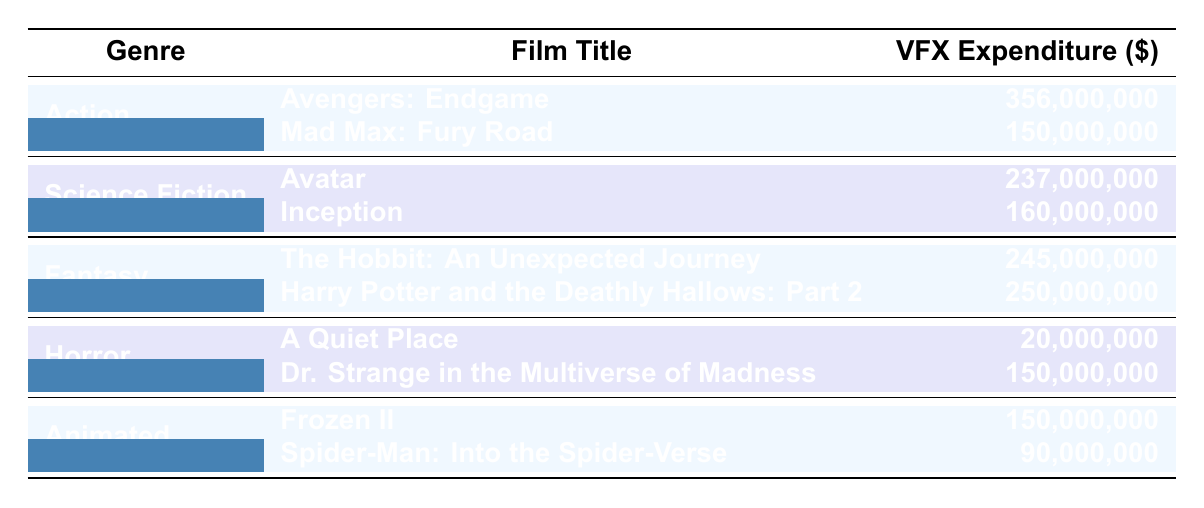What is the highest VFX expenditure in the table? Looking through the table, the highest VFX expenditure is for the film "Avengers: Endgame" which has an expenditure of 356,000,000.
Answer: 356,000,000 How much was spent on VFX for action films? For action films, the expenditures on VFX are 356,000,000 for "Avengers: Endgame" and 150,000,000 for "Mad Max: Fury Road". Adding these gives 356,000,000 + 150,000,000 = 506,000,000.
Answer: 506,000,000 Is "Avatar" an animated film? Referring to the table, "Avatar" is listed under the Science Fiction genre, not under the Animated genre.
Answer: No Which genre has the lowest total VFX expenditure? To find the genre with the lowest total VFX expenditure, we calculate the sums for each genre: Action = 506,000,000, Science Fiction = 397,000,000, Fantasy = 495,000,000, Horror = 170,000,000, Animated = 240,000,000. The lowest is Horror at 170,000,000.
Answer: Horror What is the average VFX expenditure for animated films? For animated films, "Frozen II" has an expenditure of 150,000,000 and "Spider-Man: Into the Spider-Verse" has an expenditure of 90,000,000. The average is calculated by (150,000,000 + 90,000,000) / 2 = 120,000,000.
Answer: 120,000,000 